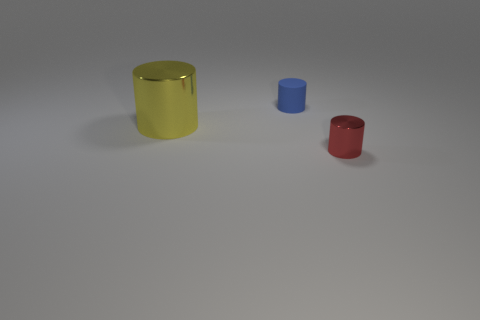Subtract all tiny metallic cylinders. How many cylinders are left? 2 Add 2 gray metal blocks. How many objects exist? 5 Subtract 1 cylinders. How many cylinders are left? 2 Add 3 big things. How many big things exist? 4 Subtract all yellow cylinders. How many cylinders are left? 2 Subtract 0 yellow cubes. How many objects are left? 3 Subtract all yellow cylinders. Subtract all green balls. How many cylinders are left? 2 Subtract all tiny shiny cylinders. Subtract all yellow matte spheres. How many objects are left? 2 Add 1 tiny rubber things. How many tiny rubber things are left? 2 